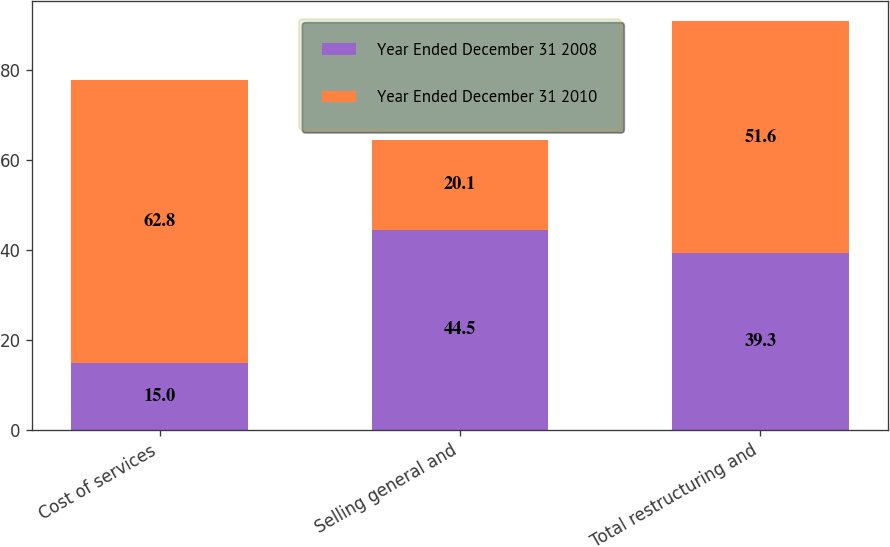Convert chart. <chart><loc_0><loc_0><loc_500><loc_500><stacked_bar_chart><ecel><fcel>Cost of services<fcel>Selling general and<fcel>Total restructuring and<nl><fcel>Year Ended December 31 2008<fcel>15<fcel>44.5<fcel>39.3<nl><fcel>Year Ended December 31 2010<fcel>62.8<fcel>20.1<fcel>51.6<nl></chart> 